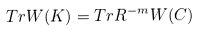Convert formula to latex. <formula><loc_0><loc_0><loc_500><loc_500>T r W ( K ) = T r R ^ { - m } W ( C )</formula> 